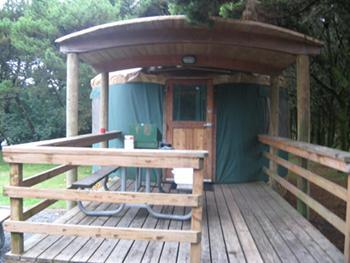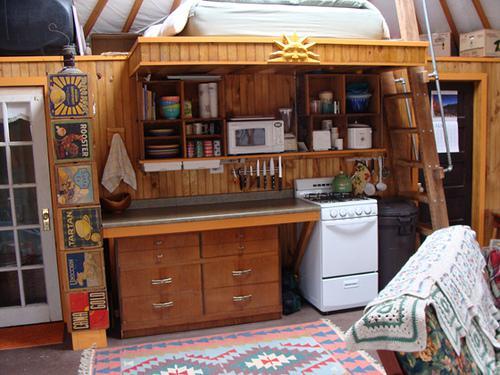The first image is the image on the left, the second image is the image on the right. Considering the images on both sides, is "At least one image shows a room with facing futon and angled bunk." valid? Answer yes or no. No. 